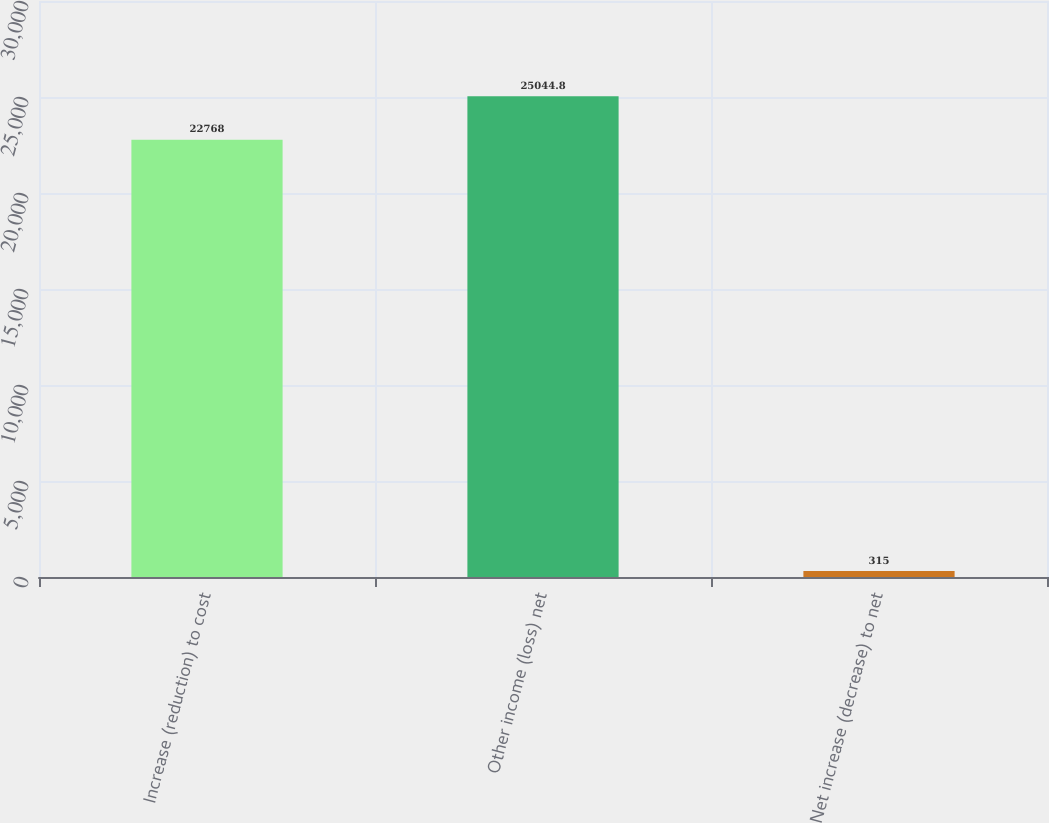Convert chart to OTSL. <chart><loc_0><loc_0><loc_500><loc_500><bar_chart><fcel>Increase (reduction) to cost<fcel>Other income (loss) net<fcel>Net increase (decrease) to net<nl><fcel>22768<fcel>25044.8<fcel>315<nl></chart> 